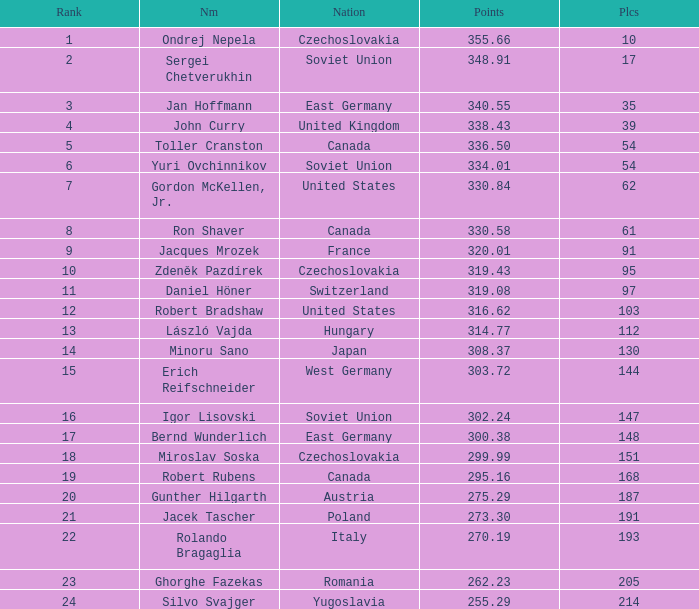Can you give me this table as a dict? {'header': ['Rank', 'Nm', 'Nation', 'Points', 'Plcs'], 'rows': [['1', 'Ondrej Nepela', 'Czechoslovakia', '355.66', '10'], ['2', 'Sergei Chetverukhin', 'Soviet Union', '348.91', '17'], ['3', 'Jan Hoffmann', 'East Germany', '340.55', '35'], ['4', 'John Curry', 'United Kingdom', '338.43', '39'], ['5', 'Toller Cranston', 'Canada', '336.50', '54'], ['6', 'Yuri Ovchinnikov', 'Soviet Union', '334.01', '54'], ['7', 'Gordon McKellen, Jr.', 'United States', '330.84', '62'], ['8', 'Ron Shaver', 'Canada', '330.58', '61'], ['9', 'Jacques Mrozek', 'France', '320.01', '91'], ['10', 'Zdeněk Pazdírek', 'Czechoslovakia', '319.43', '95'], ['11', 'Daniel Höner', 'Switzerland', '319.08', '97'], ['12', 'Robert Bradshaw', 'United States', '316.62', '103'], ['13', 'László Vajda', 'Hungary', '314.77', '112'], ['14', 'Minoru Sano', 'Japan', '308.37', '130'], ['15', 'Erich Reifschneider', 'West Germany', '303.72', '144'], ['16', 'Igor Lisovski', 'Soviet Union', '302.24', '147'], ['17', 'Bernd Wunderlich', 'East Germany', '300.38', '148'], ['18', 'Miroslav Soska', 'Czechoslovakia', '299.99', '151'], ['19', 'Robert Rubens', 'Canada', '295.16', '168'], ['20', 'Gunther Hilgarth', 'Austria', '275.29', '187'], ['21', 'Jacek Tascher', 'Poland', '273.30', '191'], ['22', 'Rolando Bragaglia', 'Italy', '270.19', '193'], ['23', 'Ghorghe Fazekas', 'Romania', '262.23', '205'], ['24', 'Silvo Svajger', 'Yugoslavia', '255.29', '214']]} How many Placings have Points smaller than 330.84, and a Name of silvo svajger? 1.0. 